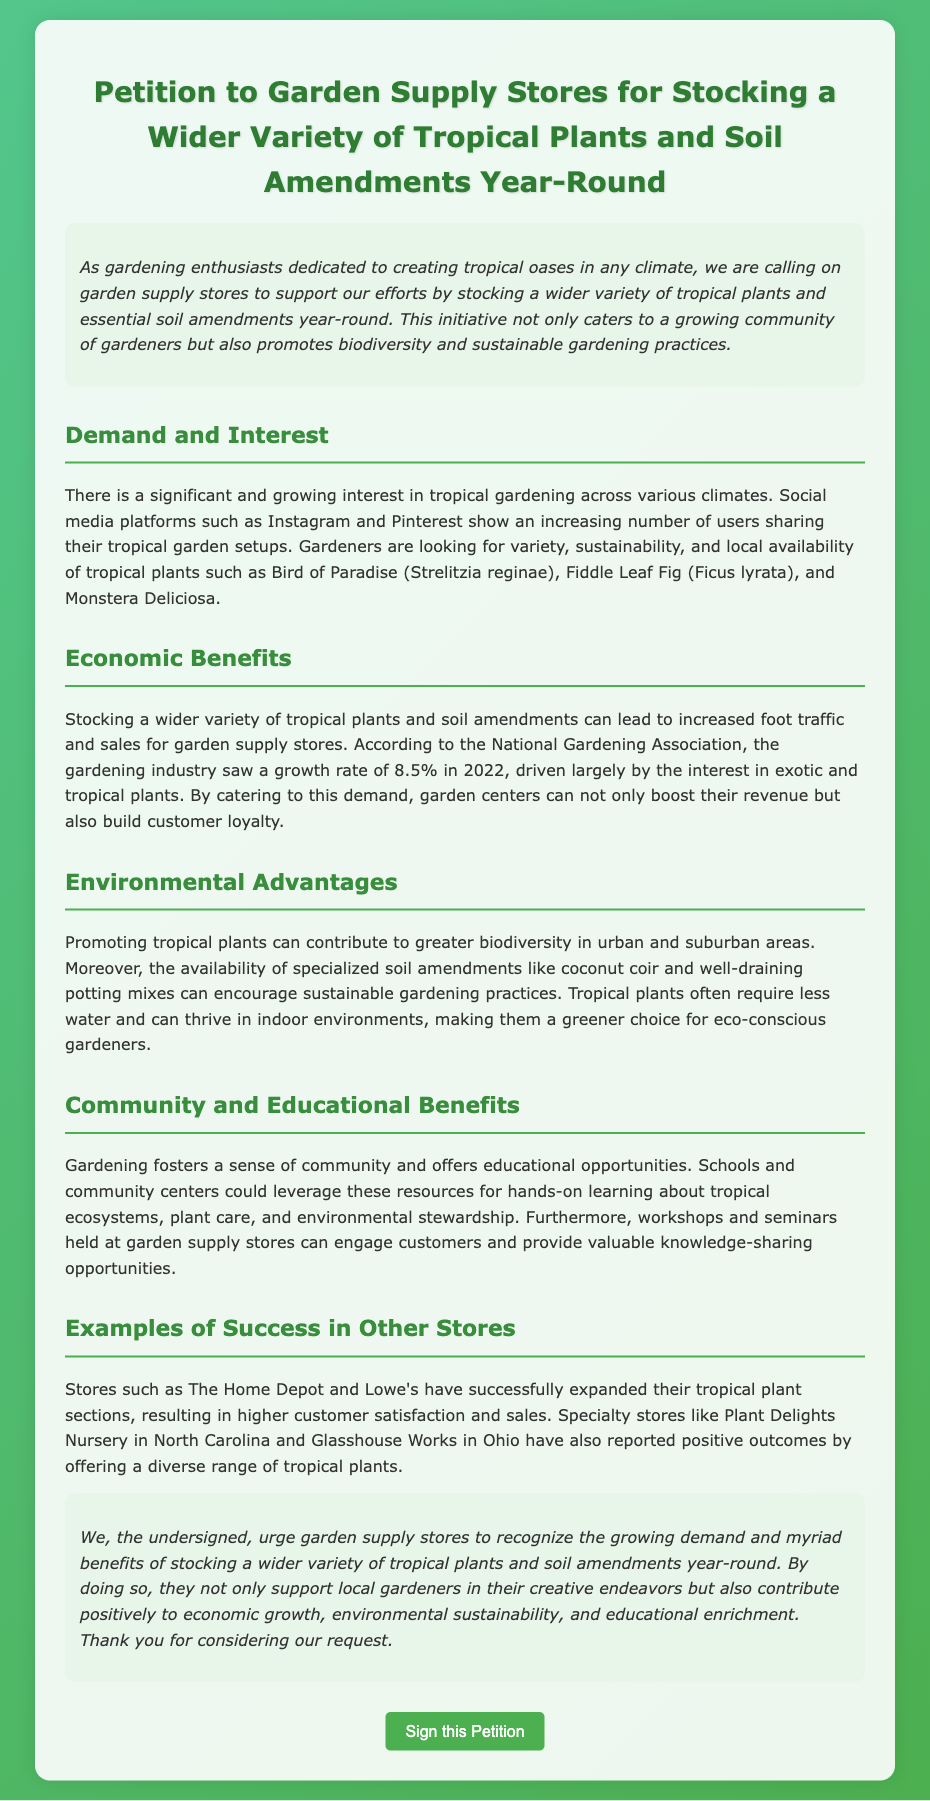What is the title of the petition? The title summarizes the purpose of the document, which is to advocate for a specific action regarding tropical plants in garden supply stores.
Answer: Petition to Garden Supply Stores for Stocking a Wider Variety of Tropical Plants and Soil Amendments Year-Round What plants are mentioned in the document? The document lists specific tropical plants that gardeners are interested in.
Answer: Bird of Paradise, Fiddle Leaf Fig, Monstera Deliciosa What growth rate did the gardening industry see in 2022? This information highlights the economic growth related to the gardening sector, specifically concerning tropical plants.
Answer: 8.5% Which stores have successfully expanded their tropical plant sections? The document provides examples of stores that have taken action and seen positive outcomes.
Answer: The Home Depot, Lowe's What is one environmental advantage mentioned? The document specifies benefits for biodiversity and sustainable gardening practices.
Answer: Greater biodiversity What type of benefits does the petition emphasize for community engagement? This highlights the social and educational aspects linked to gardening and tropical plants.
Answer: Educational opportunities How do specialized soil amendments contribute to eco-conscious gardening? This requires an understanding of the role of soil amendments mentioned in promoting sustainability.
Answer: Encourage sustainable gardening practices What is the purpose of the workshops and seminars at garden supply stores? The document indicates the role of these events in enhancing customer engagement and education.
Answer: Knowledge-sharing opportunities 